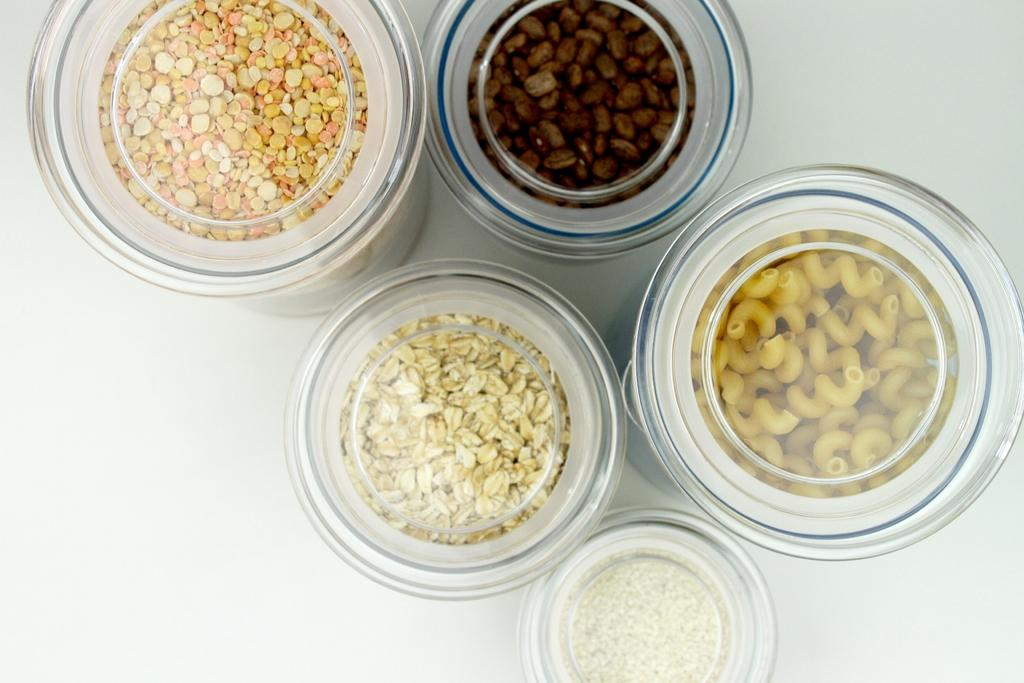What type of food items can be seen in the image? There are grains and coffee beans in the image. How are the food items stored in the image? The food items are placed in small containers. What is the color of the surface on which the containers are placed? The containers are placed on a white color surface. Can you describe any other food items visible in the image? There are other food items in the image, but their specific types are not mentioned in the provided facts. How does the person use the crayon in the image? There is no person or crayon present in the image; it only features food items in small containers on a white surface. 